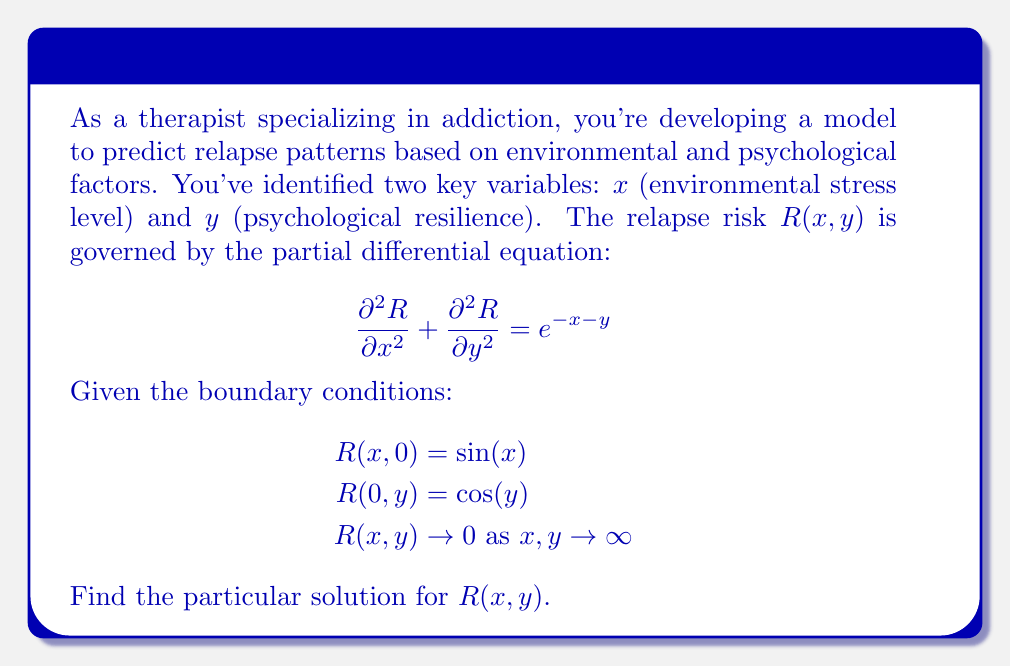Can you answer this question? To solve this partial differential equation (PDE), we'll use the method of separation of variables:

1) Assume $R(x,y) = X(x)Y(y)$

2) Substitute this into the PDE:
   $$X''Y + XY'' = e^{-x-y}$$

3) The right-hand side suggests a solution of the form $e^{-x-y}$. Let's try:
   $$R(x,y) = u(x,y) + ve^{-x-y}$$

   where $u(x,y)$ is the homogeneous solution and $ve^{-x-y}$ is the particular solution.

4) Substitute this into the original PDE:
   $$\frac{\partial^2u}{\partial x^2} + \frac{\partial^2u}{\partial y^2} + v(e^{-x-y} + e^{-x-y}) = e^{-x-y}$$

5) For this to be true for all $x$ and $y$, we must have:
   $$\frac{\partial^2u}{\partial x^2} + \frac{\partial^2u}{\partial y^2} = 0$$
   $$2v = 1$$
   $$v = \frac{1}{2}$$

6) The homogeneous solution $u(x,y)$ satisfies Laplace's equation. Given the boundary conditions, we can write:
   $$u(x,y) = A\sin(x)e^{-y} + B\cos(y)e^{-x}$$

7) Now, let's apply the boundary conditions to the full solution:
   $$R(x,y) = A\sin(x)e^{-y} + B\cos(y)e^{-x} + \frac{1}{2}e^{-x-y}$$

   At $y=0$: $R(x,0) = A\sin(x) + B + \frac{1}{2}e^{-x} = \sin(x)$
   At $x=0$: $R(0,y) = B\cos(y) + \frac{1}{2}e^{-y} = \cos(y)$

8) From these conditions, we can deduce:
   $A = 1$
   $B = \frac{1}{2}$

Therefore, the particular solution is:
$$R(x,y) = \sin(x)e^{-y} + \frac{1}{2}\cos(y)e^{-x} + \frac{1}{2}e^{-x-y}$$

This solution satisfies all given conditions, including approaching 0 as $x$ and $y$ approach infinity.
Answer: $R(x,y) = \sin(x)e^{-y} + \frac{1}{2}\cos(y)e^{-x} + \frac{1}{2}e^{-x-y}$ 